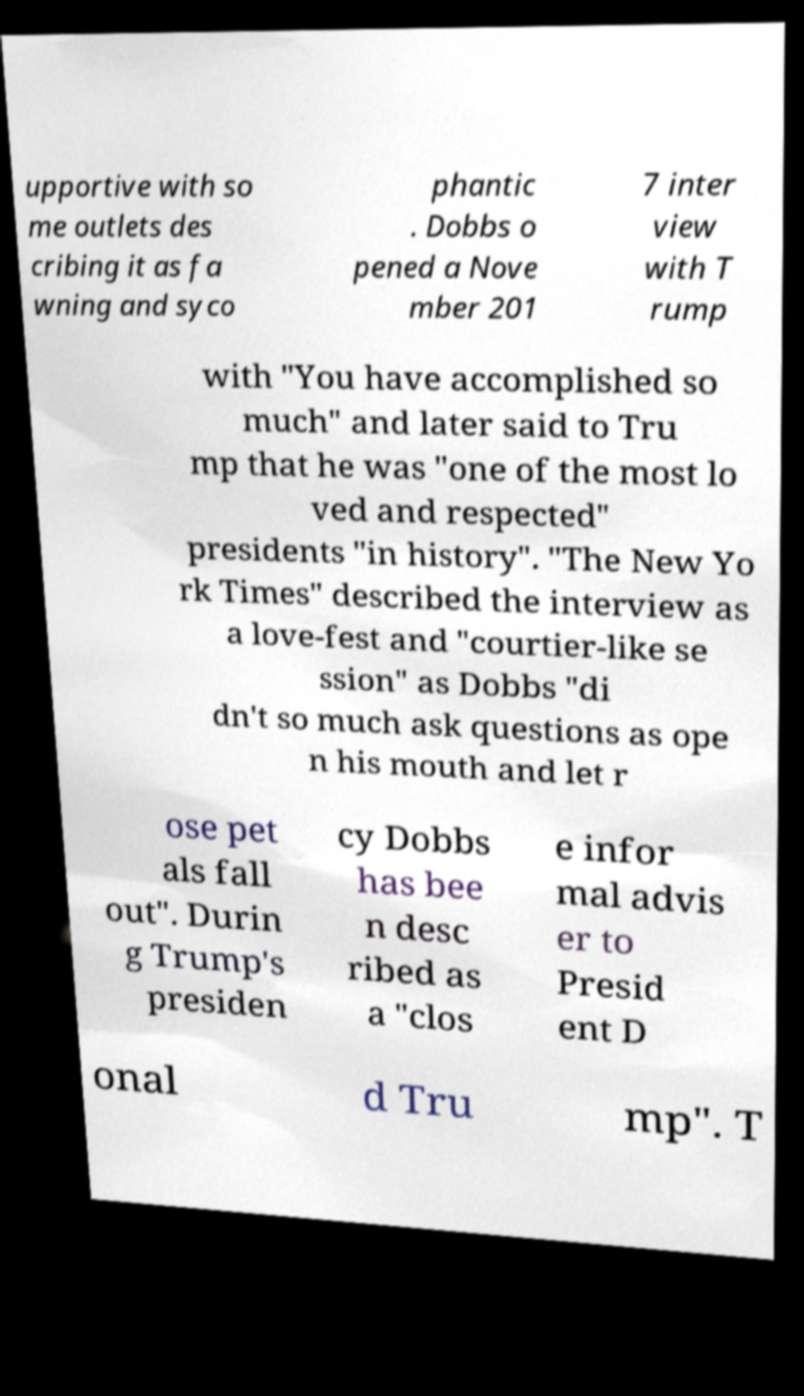What messages or text are displayed in this image? I need them in a readable, typed format. upportive with so me outlets des cribing it as fa wning and syco phantic . Dobbs o pened a Nove mber 201 7 inter view with T rump with "You have accomplished so much" and later said to Tru mp that he was "one of the most lo ved and respected" presidents "in history". "The New Yo rk Times" described the interview as a love-fest and "courtier-like se ssion" as Dobbs "di dn't so much ask questions as ope n his mouth and let r ose pet als fall out". Durin g Trump's presiden cy Dobbs has bee n desc ribed as a "clos e infor mal advis er to Presid ent D onal d Tru mp". T 